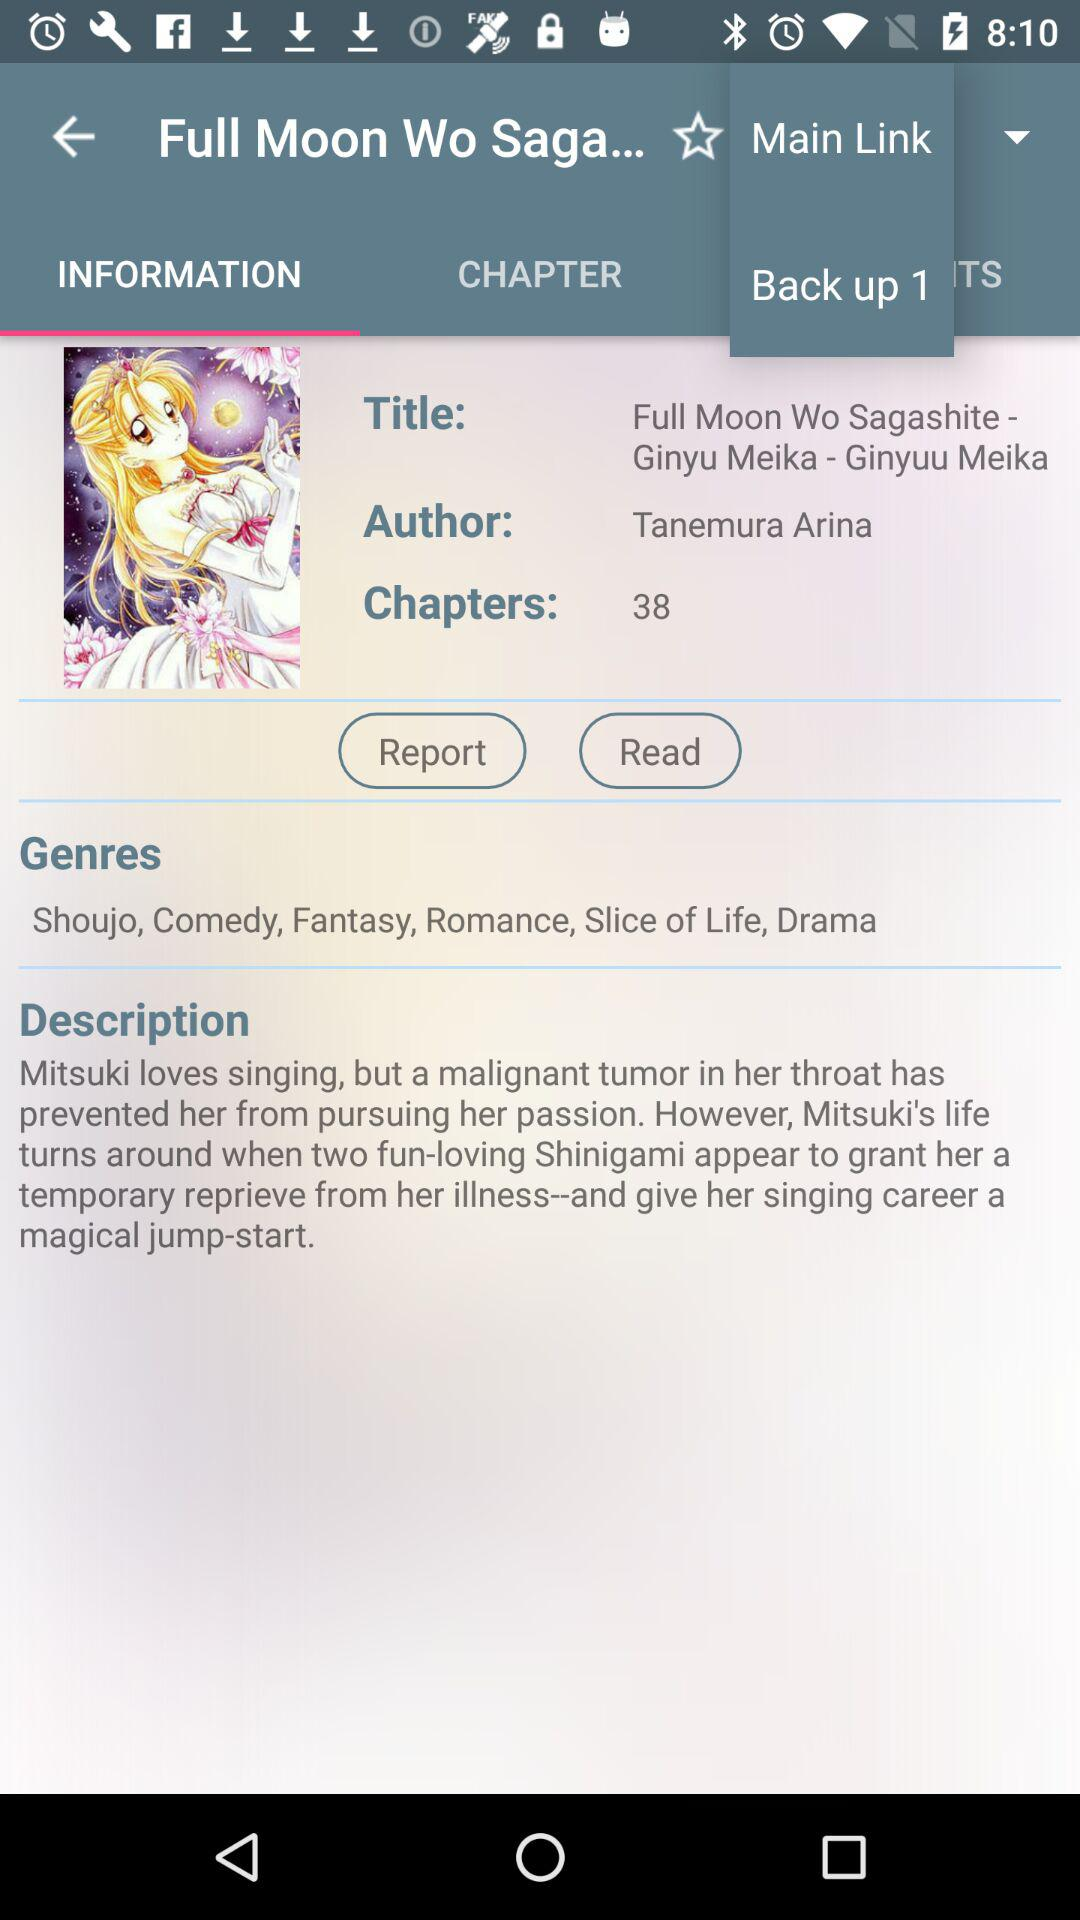What is the title of the book? The title of the book is "Full Moon Wo Sagashite - Ginyu Meika - Ginyuu Meika". 